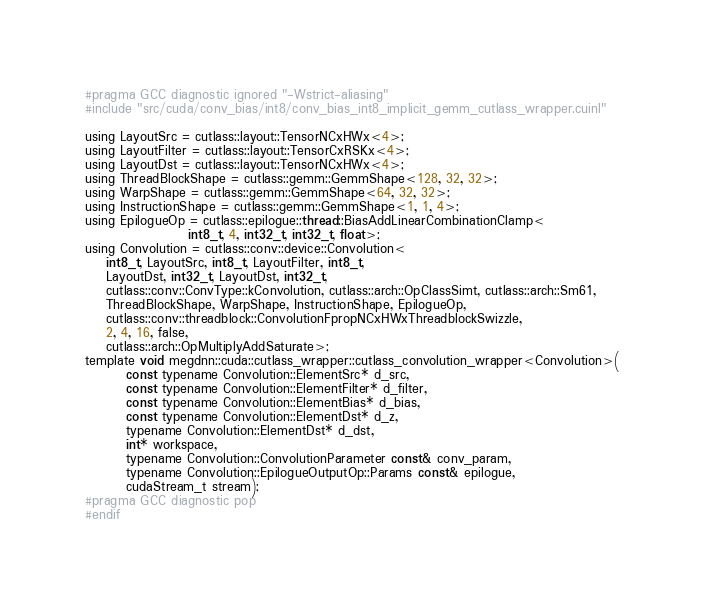Convert code to text. <code><loc_0><loc_0><loc_500><loc_500><_Cuda_>#pragma GCC diagnostic ignored "-Wstrict-aliasing"
#include "src/cuda/conv_bias/int8/conv_bias_int8_implicit_gemm_cutlass_wrapper.cuinl"

using LayoutSrc = cutlass::layout::TensorNCxHWx<4>;
using LayoutFilter = cutlass::layout::TensorCxRSKx<4>;
using LayoutDst = cutlass::layout::TensorNCxHWx<4>;
using ThreadBlockShape = cutlass::gemm::GemmShape<128, 32, 32>;
using WarpShape = cutlass::gemm::GemmShape<64, 32, 32>;
using InstructionShape = cutlass::gemm::GemmShape<1, 1, 4>;
using EpilogueOp = cutlass::epilogue::thread::BiasAddLinearCombinationClamp<
                    int8_t, 4, int32_t, int32_t, float>;
using Convolution = cutlass::conv::device::Convolution<
    int8_t, LayoutSrc, int8_t, LayoutFilter, int8_t, 
    LayoutDst, int32_t, LayoutDst, int32_t, 
    cutlass::conv::ConvType::kConvolution, cutlass::arch::OpClassSimt, cutlass::arch::Sm61, 
    ThreadBlockShape, WarpShape, InstructionShape, EpilogueOp, 
    cutlass::conv::threadblock::ConvolutionFpropNCxHWxThreadblockSwizzle, 
    2, 4, 16, false, 
    cutlass::arch::OpMultiplyAddSaturate>;
template void megdnn::cuda::cutlass_wrapper::cutlass_convolution_wrapper<Convolution>(
        const typename Convolution::ElementSrc* d_src, 
        const typename Convolution::ElementFilter* d_filter, 
        const typename Convolution::ElementBias* d_bias, 
        const typename Convolution::ElementDst* d_z, 
        typename Convolution::ElementDst* d_dst, 
        int* workspace, 
        typename Convolution::ConvolutionParameter const& conv_param, 
        typename Convolution::EpilogueOutputOp::Params const& epilogue, 
        cudaStream_t stream);
#pragma GCC diagnostic pop
#endif
</code> 